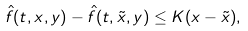Convert formula to latex. <formula><loc_0><loc_0><loc_500><loc_500>\hat { f } ( t , x , y ) - \hat { f } ( t , \tilde { x } , y ) \leq K ( x - \tilde { x } ) ,</formula> 